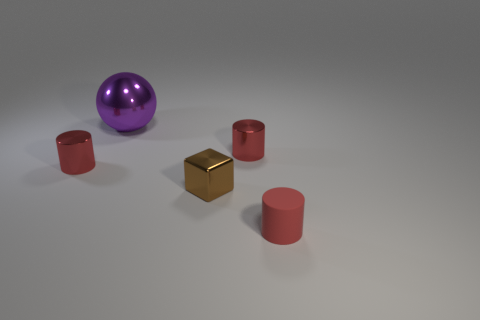Subtract all red cylinders. How many were subtracted if there are1red cylinders left? 2 Add 3 big purple things. How many objects exist? 8 Subtract all balls. How many objects are left? 4 Subtract 0 cyan cylinders. How many objects are left? 5 Subtract all tiny blocks. Subtract all tiny matte cylinders. How many objects are left? 3 Add 4 purple objects. How many purple objects are left? 5 Add 2 balls. How many balls exist? 3 